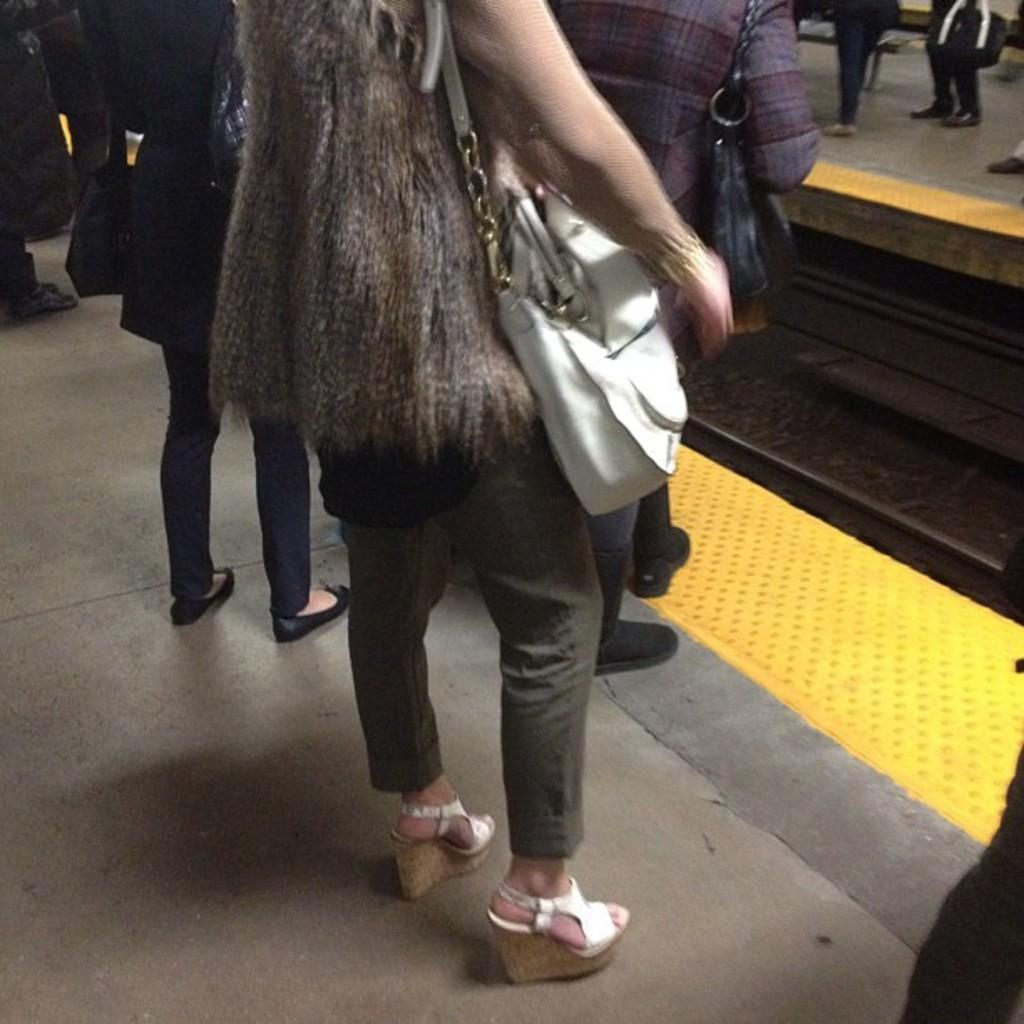How many people are visible in the image? There are many people standing in the image. Can you describe the accessories worn by the woman in the image? The woman is wearing a handbag in the image. What is the woman wearing on her body in the image? The woman is wearing a white saddle in the image. What type of wire or cord is being used by the rabbits in the image? There are no rabbits present in the image, so there is no wire or cord being used by them. 